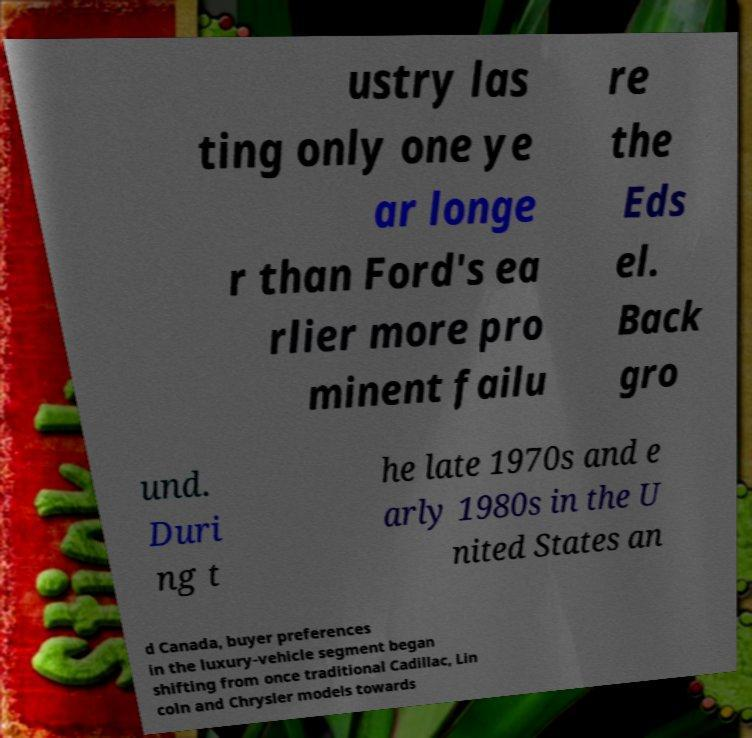Please identify and transcribe the text found in this image. ustry las ting only one ye ar longe r than Ford's ea rlier more pro minent failu re the Eds el. Back gro und. Duri ng t he late 1970s and e arly 1980s in the U nited States an d Canada, buyer preferences in the luxury-vehicle segment began shifting from once traditional Cadillac, Lin coln and Chrysler models towards 